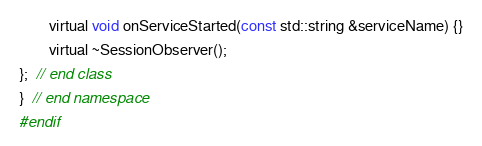Convert code to text. <code><loc_0><loc_0><loc_500><loc_500><_C_>
        virtual void onServiceStarted(const std::string &serviceName) {}

        virtual ~SessionObserver();

};  // end class

}  // end namespace

#endif
</code> 